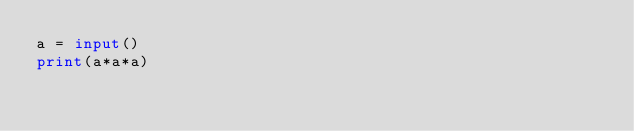<code> <loc_0><loc_0><loc_500><loc_500><_Python_>a = input()
print(a*a*a)
</code> 